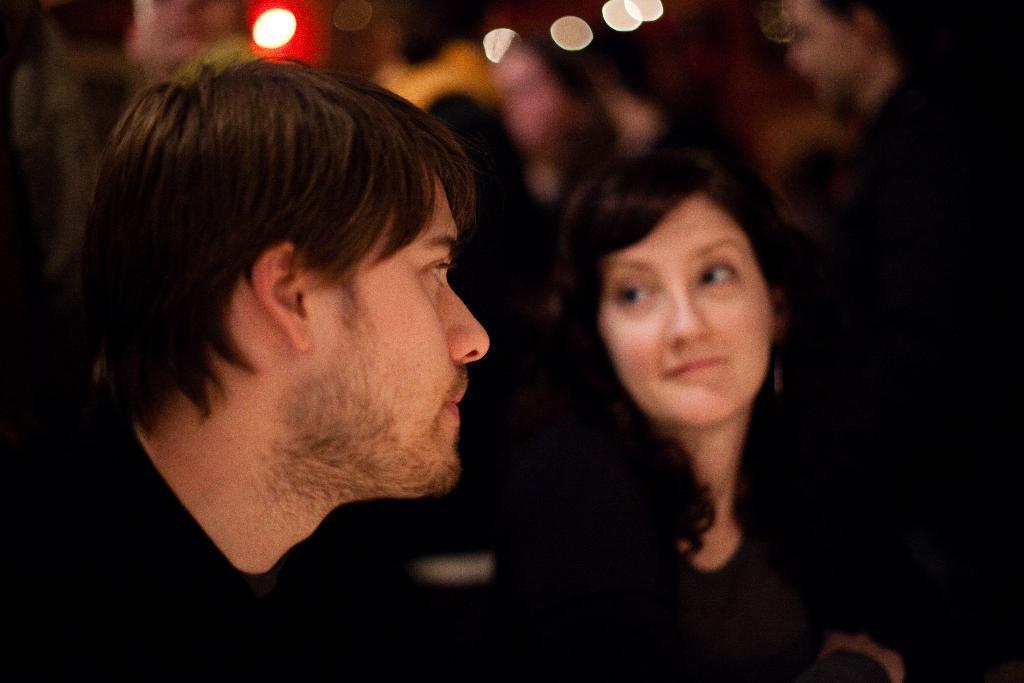Describe this image in one or two sentences. In this image there are two men, there is a woman, there are lights towards the top of the image, the background of the image is blurred. 